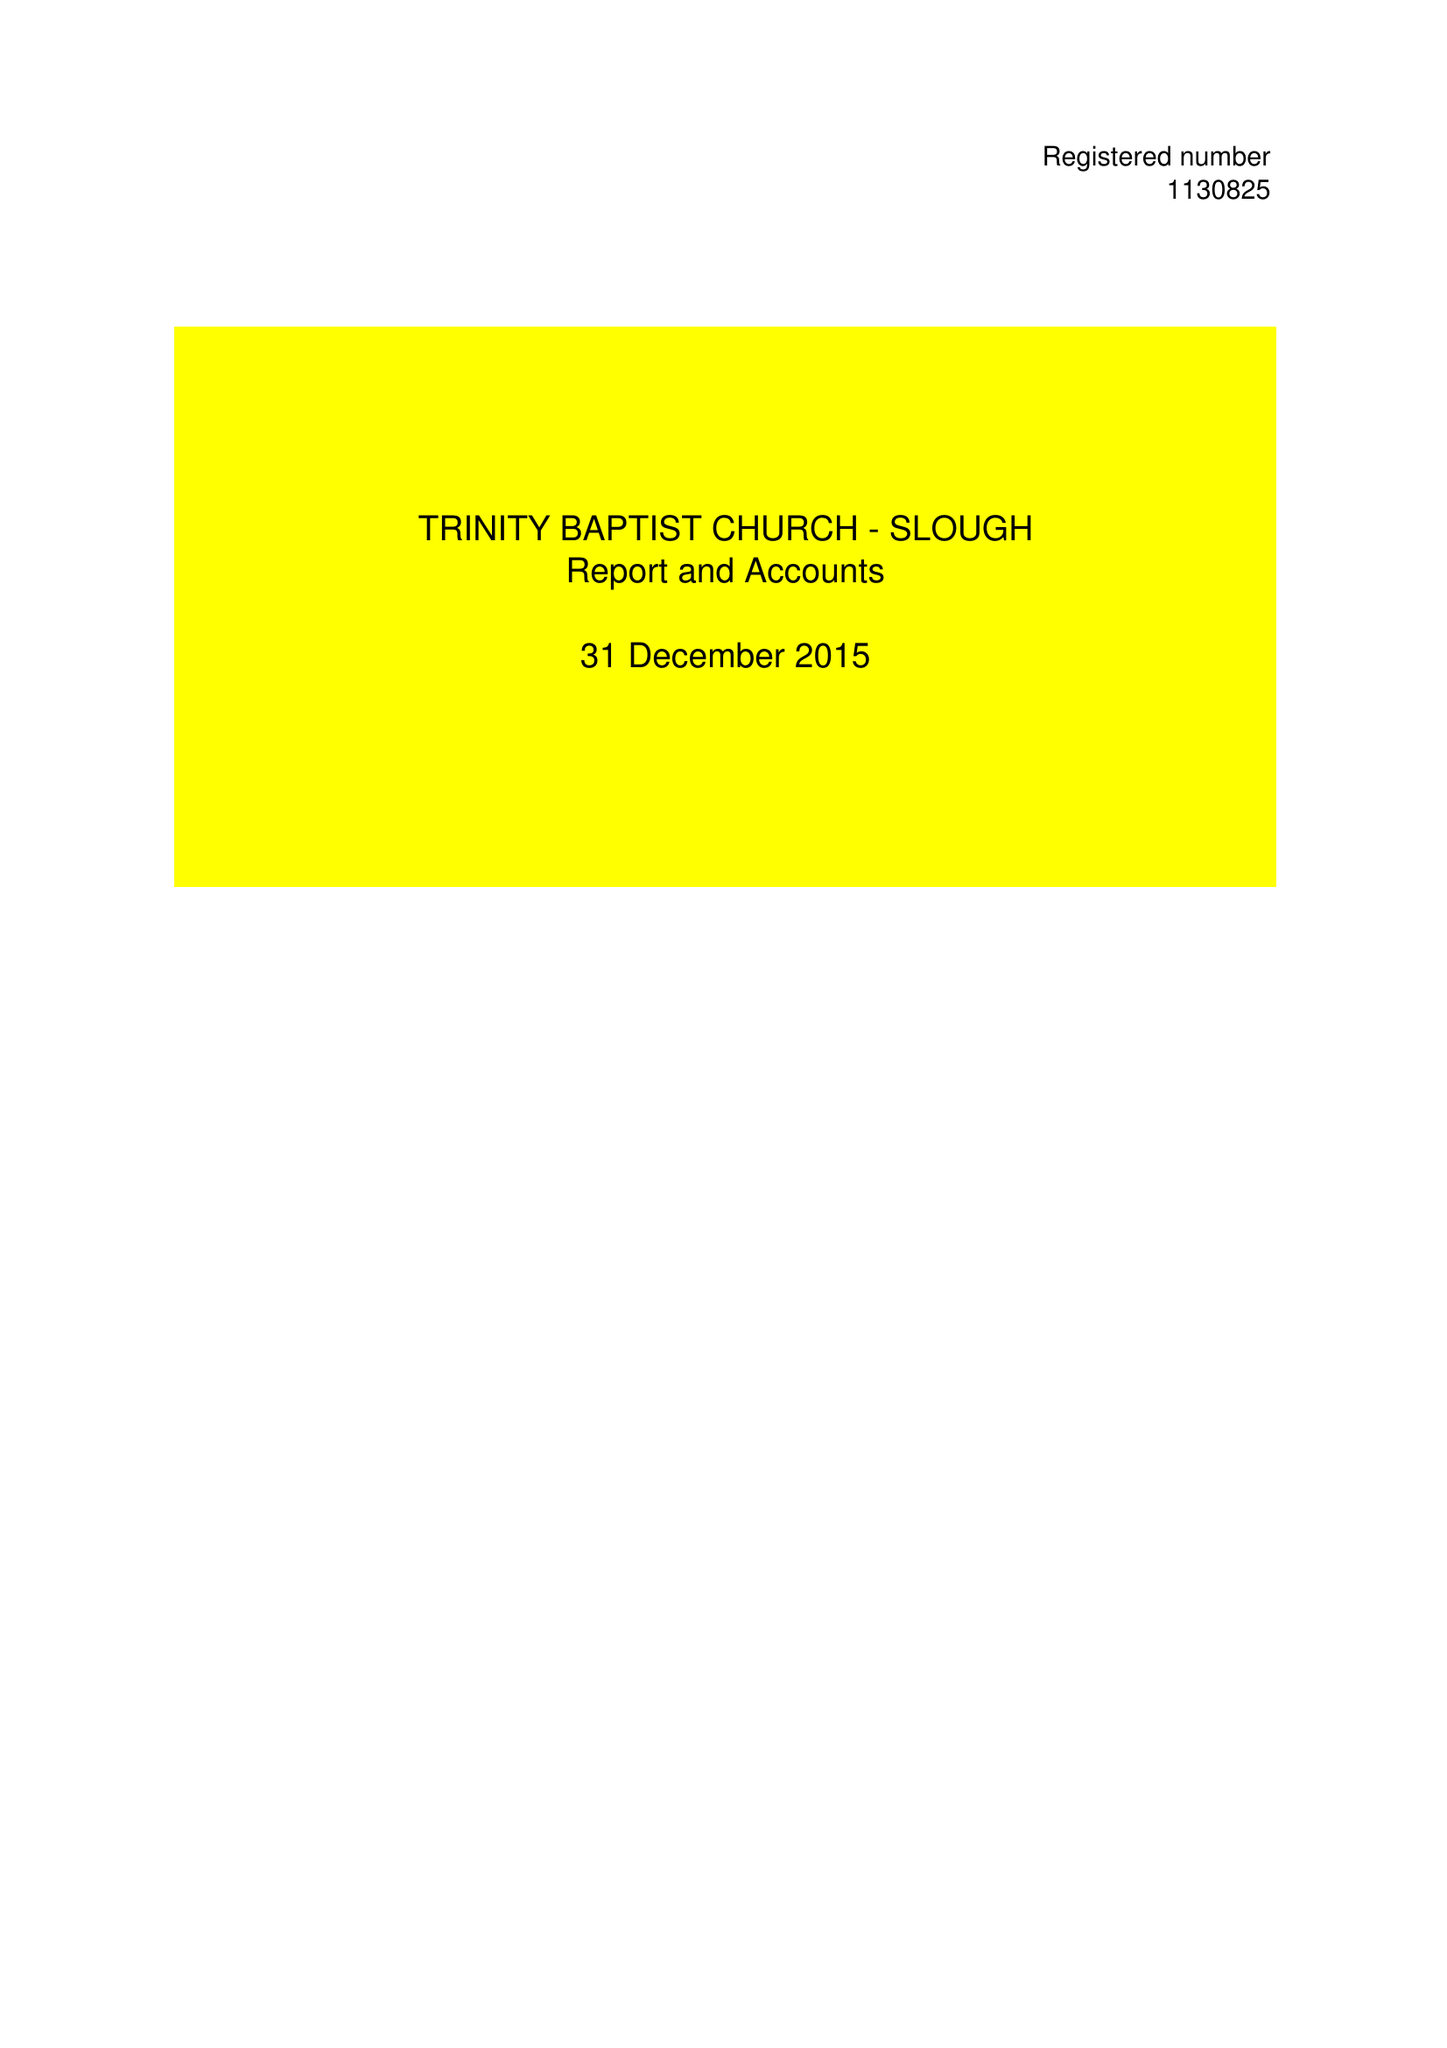What is the value for the charity_name?
Answer the question using a single word or phrase. Trinity Baptist Church Slough 